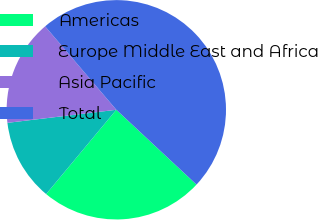Convert chart. <chart><loc_0><loc_0><loc_500><loc_500><pie_chart><fcel>Americas<fcel>Europe Middle East and Africa<fcel>Asia Pacific<fcel>Total<nl><fcel>24.1%<fcel>12.05%<fcel>15.66%<fcel>48.19%<nl></chart> 